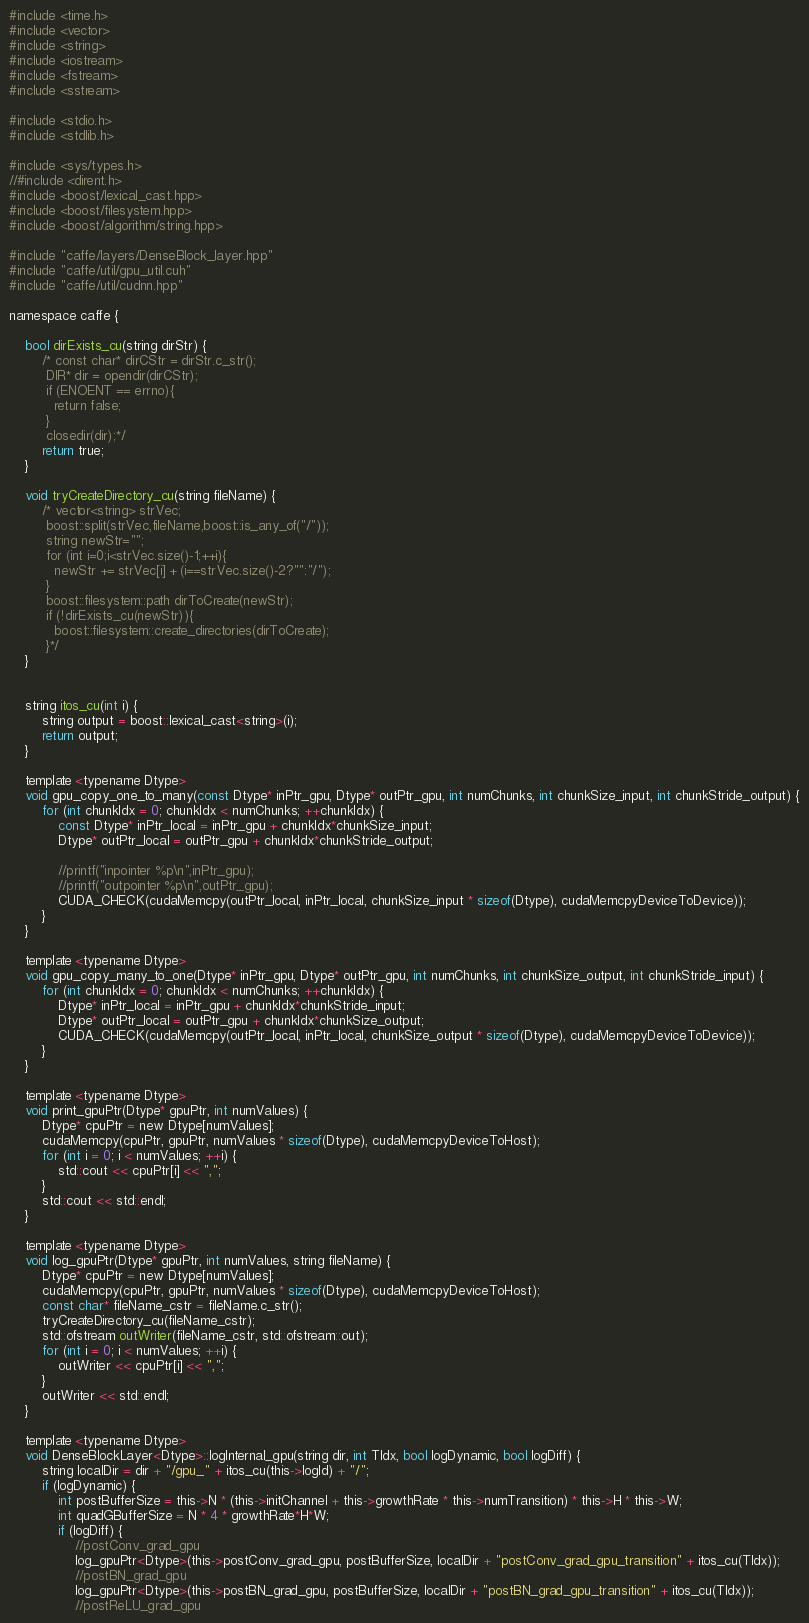<code> <loc_0><loc_0><loc_500><loc_500><_Cuda_>#include <time.h>
#include <vector>
#include <string>
#include <iostream>
#include <fstream>
#include <sstream>

#include <stdio.h>
#include <stdlib.h>

#include <sys/types.h>
//#include <dirent.h>
#include <boost/lexical_cast.hpp>
#include <boost/filesystem.hpp>
#include <boost/algorithm/string.hpp>

#include "caffe/layers/DenseBlock_layer.hpp"
#include "caffe/util/gpu_util.cuh"
#include "caffe/util/cudnn.hpp"

namespace caffe {

	bool dirExists_cu(string dirStr) {
		/* const char* dirCStr = dirStr.c_str();
		 DIR* dir = opendir(dirCStr);
		 if (ENOENT == errno){
		   return false;
		 }
		 closedir(dir);*/
		return true;
	}

	void tryCreateDirectory_cu(string fileName) {
		/* vector<string> strVec;
		 boost::split(strVec,fileName,boost::is_any_of("/"));
		 string newStr="";
		 for (int i=0;i<strVec.size()-1;++i){
		   newStr += strVec[i] + (i==strVec.size()-2?"":"/");
		 }
		 boost::filesystem::path dirToCreate(newStr);
		 if (!dirExists_cu(newStr)){
		   boost::filesystem::create_directories(dirToCreate);
		 }*/
	}


	string itos_cu(int i) {
		string output = boost::lexical_cast<string>(i);
		return output;
	}

	template <typename Dtype>
	void gpu_copy_one_to_many(const Dtype* inPtr_gpu, Dtype* outPtr_gpu, int numChunks, int chunkSize_input, int chunkStride_output) {
		for (int chunkIdx = 0; chunkIdx < numChunks; ++chunkIdx) {
			const Dtype* inPtr_local = inPtr_gpu + chunkIdx*chunkSize_input;
			Dtype* outPtr_local = outPtr_gpu + chunkIdx*chunkStride_output;

			//printf("inpointer %p\n",inPtr_gpu);
			//printf("outpointer %p\n",outPtr_gpu);
			CUDA_CHECK(cudaMemcpy(outPtr_local, inPtr_local, chunkSize_input * sizeof(Dtype), cudaMemcpyDeviceToDevice));
		}
	}

	template <typename Dtype>
	void gpu_copy_many_to_one(Dtype* inPtr_gpu, Dtype* outPtr_gpu, int numChunks, int chunkSize_output, int chunkStride_input) {
		for (int chunkIdx = 0; chunkIdx < numChunks; ++chunkIdx) {
			Dtype* inPtr_local = inPtr_gpu + chunkIdx*chunkStride_input;
			Dtype* outPtr_local = outPtr_gpu + chunkIdx*chunkSize_output;
			CUDA_CHECK(cudaMemcpy(outPtr_local, inPtr_local, chunkSize_output * sizeof(Dtype), cudaMemcpyDeviceToDevice));
		}
	}

	template <typename Dtype>
	void print_gpuPtr(Dtype* gpuPtr, int numValues) {
		Dtype* cpuPtr = new Dtype[numValues];
		cudaMemcpy(cpuPtr, gpuPtr, numValues * sizeof(Dtype), cudaMemcpyDeviceToHost);
		for (int i = 0; i < numValues; ++i) {
			std::cout << cpuPtr[i] << ",";
		}
		std::cout << std::endl;
	}

	template <typename Dtype>
	void log_gpuPtr(Dtype* gpuPtr, int numValues, string fileName) {
		Dtype* cpuPtr = new Dtype[numValues];
		cudaMemcpy(cpuPtr, gpuPtr, numValues * sizeof(Dtype), cudaMemcpyDeviceToHost);
		const char* fileName_cstr = fileName.c_str();
		tryCreateDirectory_cu(fileName_cstr);
		std::ofstream outWriter(fileName_cstr, std::ofstream::out);
		for (int i = 0; i < numValues; ++i) {
			outWriter << cpuPtr[i] << ",";
		}
		outWriter << std::endl;
	}

	template <typename Dtype>
	void DenseBlockLayer<Dtype>::logInternal_gpu(string dir, int TIdx, bool logDynamic, bool logDiff) {
		string localDir = dir + "/gpu_" + itos_cu(this->logId) + "/";
		if (logDynamic) {
			int postBufferSize = this->N * (this->initChannel + this->growthRate * this->numTransition) * this->H * this->W;
			int quadGBufferSize = N * 4 * growthRate*H*W;
			if (logDiff) {
				//postConv_grad_gpu
				log_gpuPtr<Dtype>(this->postConv_grad_gpu, postBufferSize, localDir + "postConv_grad_gpu_transition" + itos_cu(TIdx));
				//postBN_grad_gpu
				log_gpuPtr<Dtype>(this->postBN_grad_gpu, postBufferSize, localDir + "postBN_grad_gpu_transition" + itos_cu(TIdx));
				//postReLU_grad_gpu</code> 